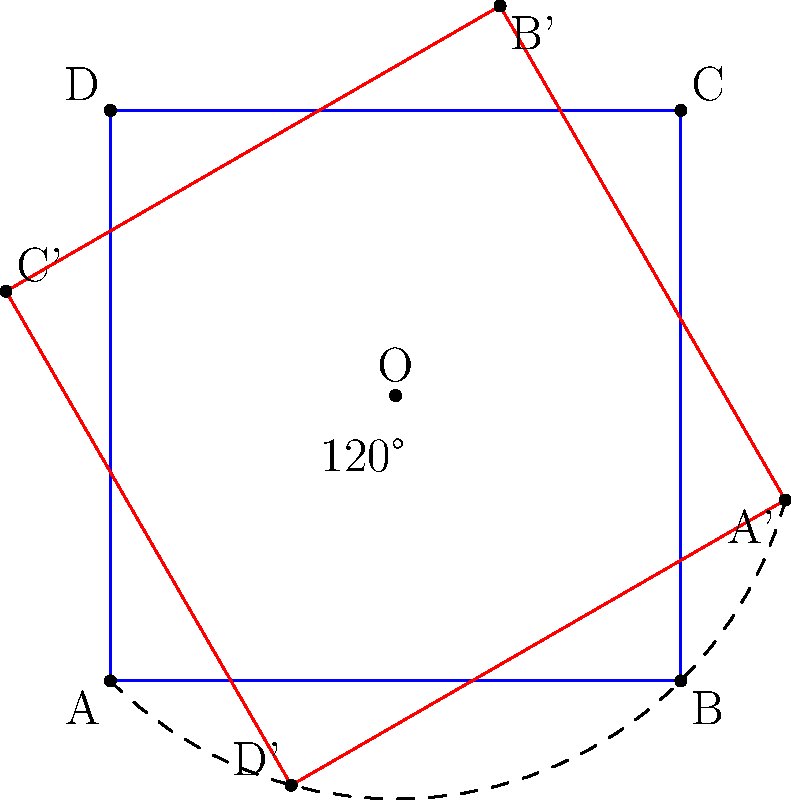In the NBN HFC network design, a square-shaped coverage area needs to be rotated to optimize signal distribution. The square ABCD with side length 2 units is centered at point O(1,1). If the square is rotated 120° counterclockwise around point O, what are the coordinates of point C after rotation? To solve this problem, we'll follow these steps:

1) First, identify the initial coordinates of point C:
   C is at (2,2) before rotation.

2) The center of rotation O is at (1,1).

3) To rotate a point (x,y) by an angle θ around the origin (0,0), we use these formulas:
   x' = x cos(θ) - y sin(θ)
   y' = x sin(θ) + y cos(θ)

4) However, since we're rotating around (1,1), we need to:
   a) Translate the point so that O becomes the origin
   b) Rotate
   c) Translate back

5) Translating C(2,2) so that O becomes the origin:
   C_translated = (1,1)

6) Now rotate this point 120° (or 2π/3 radians) using the rotation formulas:
   x' = 1 * cos(2π/3) - 1 * sin(2π/3) = -1/2 - √3/2
   y' = 1 * sin(2π/3) + 1 * cos(2π/3) = √3/2 - 1/2

7) Translate back by adding (1,1):
   C_rotated = (1-1/2-√3/2, 1+√3/2-1/2)
             = (1/2-√3/2, 1/2+√3/2)

8) Simplify:
   C_rotated = (0.5-0.866, 0.5+0.866) ≈ (-0.366, 1.366)
Answer: $(-0.366, 1.366)$ 